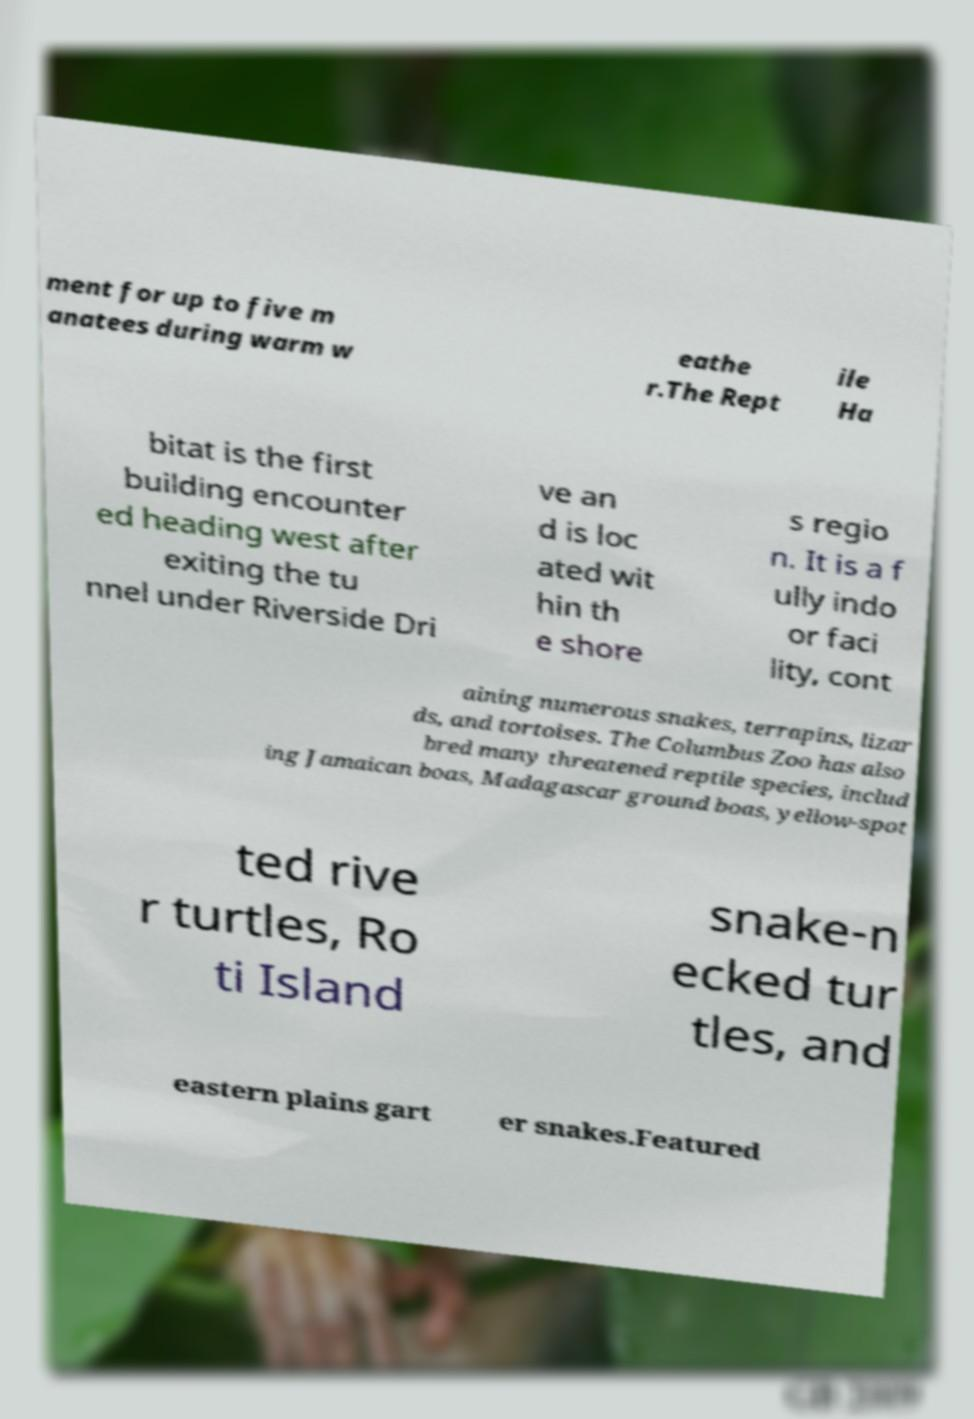Please read and relay the text visible in this image. What does it say? ment for up to five m anatees during warm w eathe r.The Rept ile Ha bitat is the first building encounter ed heading west after exiting the tu nnel under Riverside Dri ve an d is loc ated wit hin th e shore s regio n. It is a f ully indo or faci lity, cont aining numerous snakes, terrapins, lizar ds, and tortoises. The Columbus Zoo has also bred many threatened reptile species, includ ing Jamaican boas, Madagascar ground boas, yellow-spot ted rive r turtles, Ro ti Island snake-n ecked tur tles, and eastern plains gart er snakes.Featured 